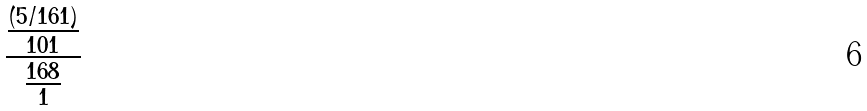<formula> <loc_0><loc_0><loc_500><loc_500>\frac { \frac { ( 5 / 1 6 1 ) } { 1 0 1 } } { \frac { 1 6 8 } { 1 } }</formula> 